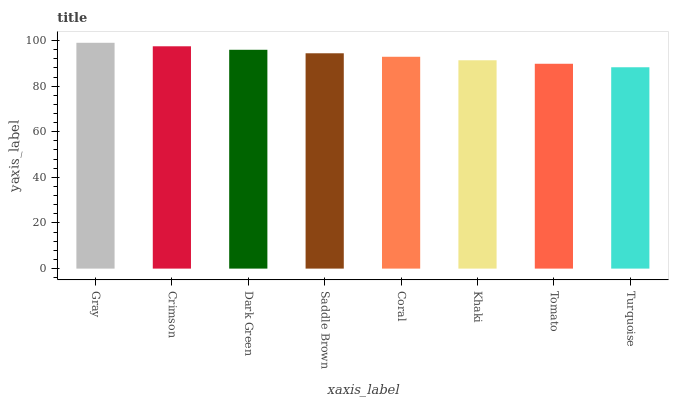Is Turquoise the minimum?
Answer yes or no. Yes. Is Gray the maximum?
Answer yes or no. Yes. Is Crimson the minimum?
Answer yes or no. No. Is Crimson the maximum?
Answer yes or no. No. Is Gray greater than Crimson?
Answer yes or no. Yes. Is Crimson less than Gray?
Answer yes or no. Yes. Is Crimson greater than Gray?
Answer yes or no. No. Is Gray less than Crimson?
Answer yes or no. No. Is Saddle Brown the high median?
Answer yes or no. Yes. Is Coral the low median?
Answer yes or no. Yes. Is Tomato the high median?
Answer yes or no. No. Is Khaki the low median?
Answer yes or no. No. 